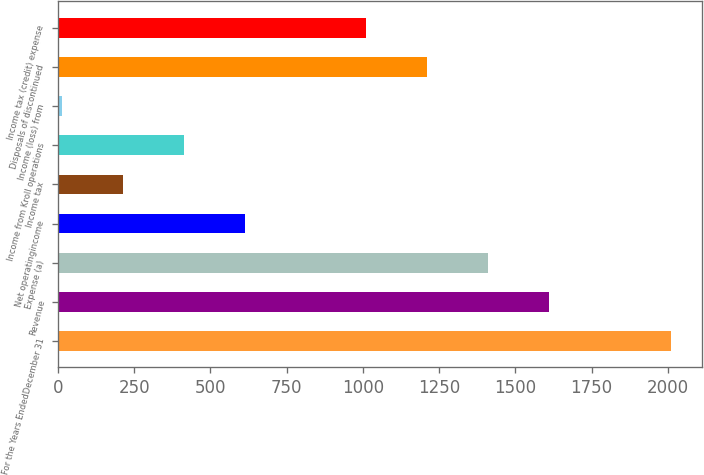Convert chart to OTSL. <chart><loc_0><loc_0><loc_500><loc_500><bar_chart><fcel>For the Years EndedDecember 31<fcel>Revenue<fcel>Expense (a)<fcel>Net operatingincome<fcel>Income tax<fcel>Income from Kroll operations<fcel>Income (loss) from<fcel>Disposals of discontinued<fcel>Income tax (credit) expense<nl><fcel>2010<fcel>1610.6<fcel>1410.9<fcel>612.1<fcel>212.7<fcel>412.4<fcel>13<fcel>1211.2<fcel>1011.5<nl></chart> 